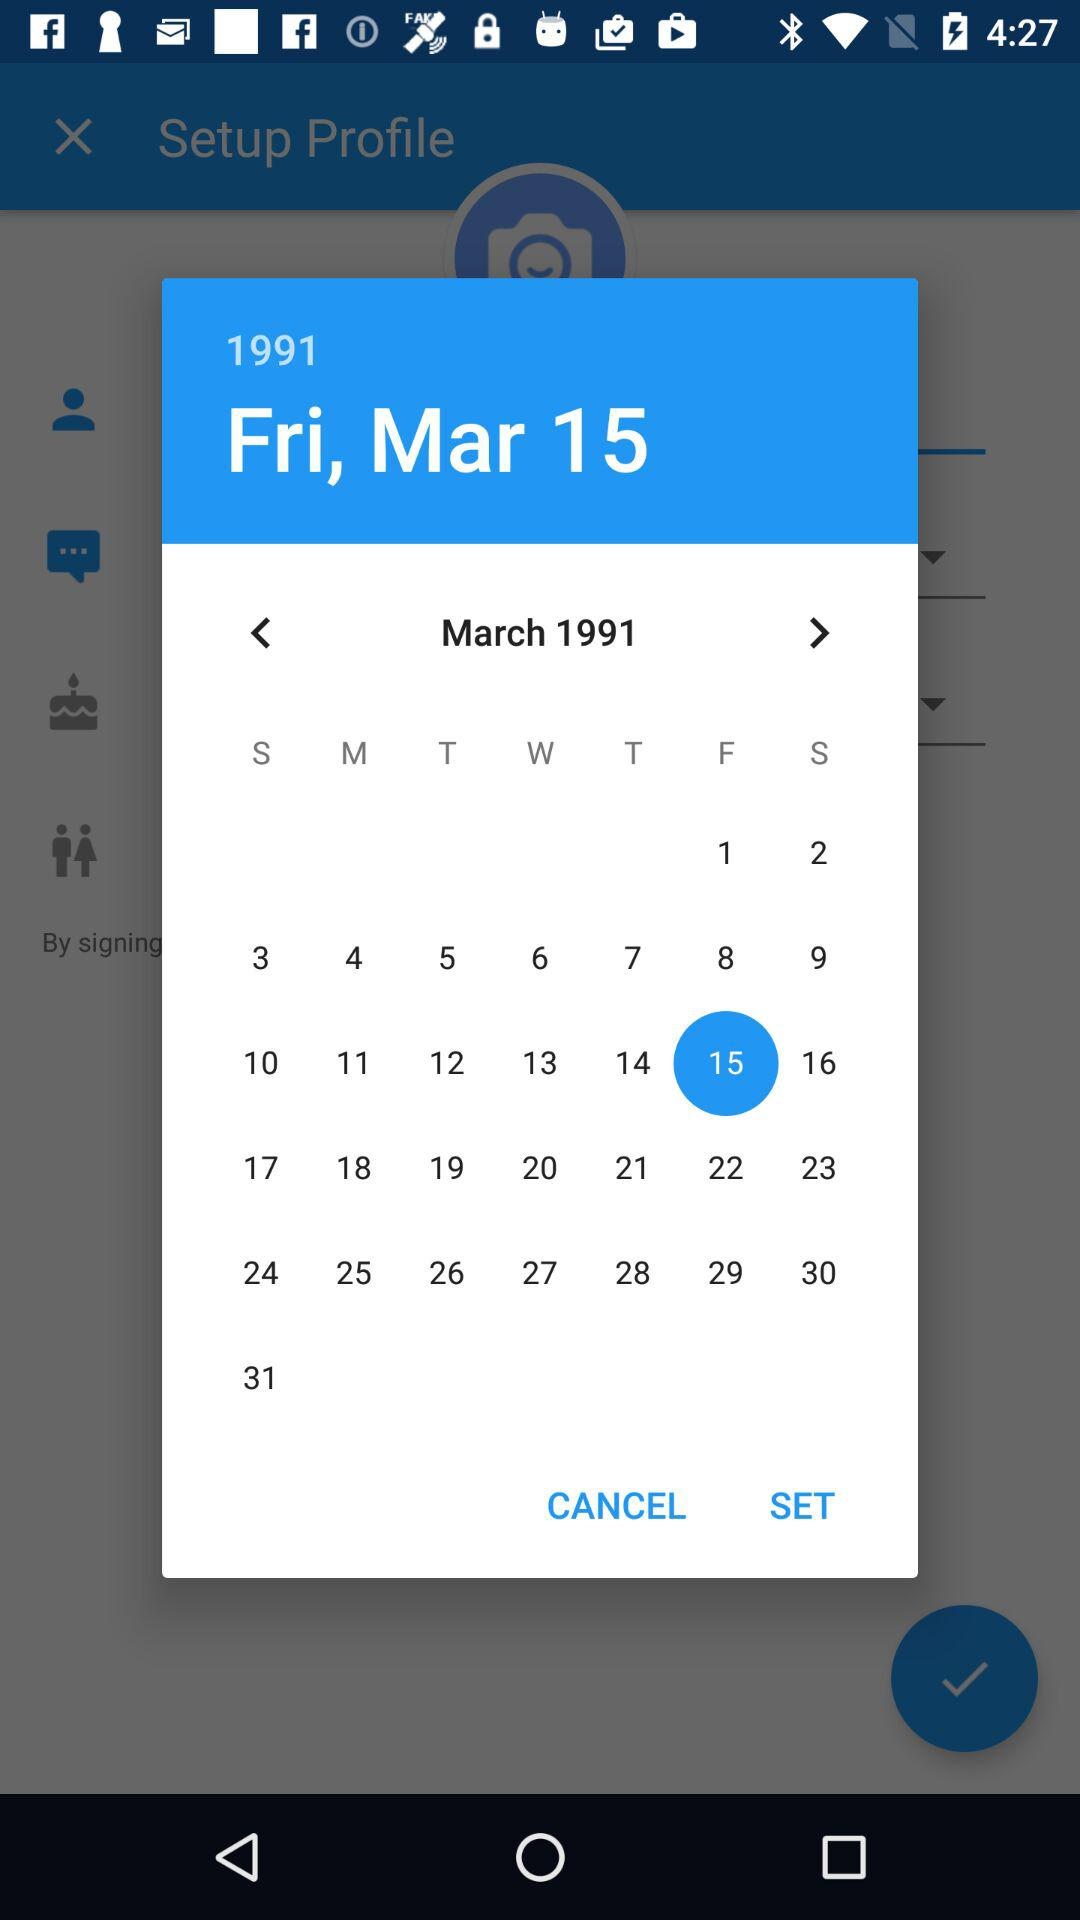What is the year? The year is 1991. 